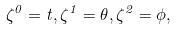<formula> <loc_0><loc_0><loc_500><loc_500>\zeta ^ { 0 } = t , \zeta ^ { 1 } = \theta , \zeta ^ { 2 } = \phi ,</formula> 